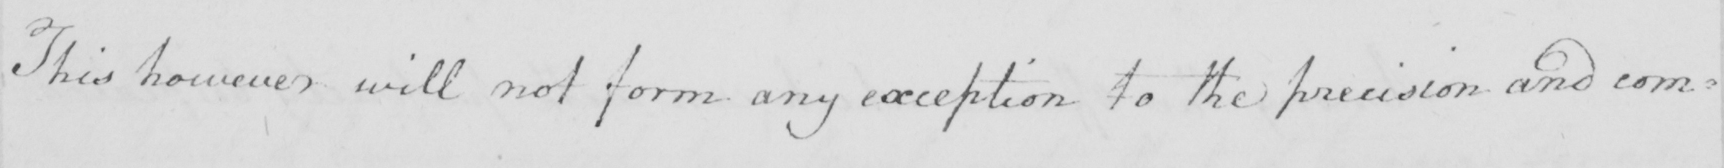Please transcribe the handwritten text in this image. This however will not form any exception to the precision and com : 